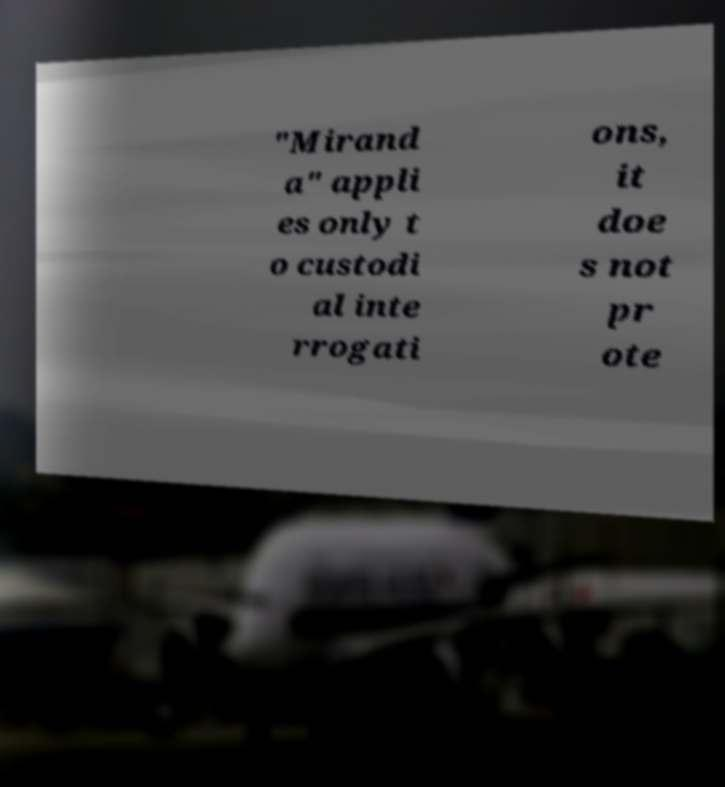Could you assist in decoding the text presented in this image and type it out clearly? "Mirand a" appli es only t o custodi al inte rrogati ons, it doe s not pr ote 